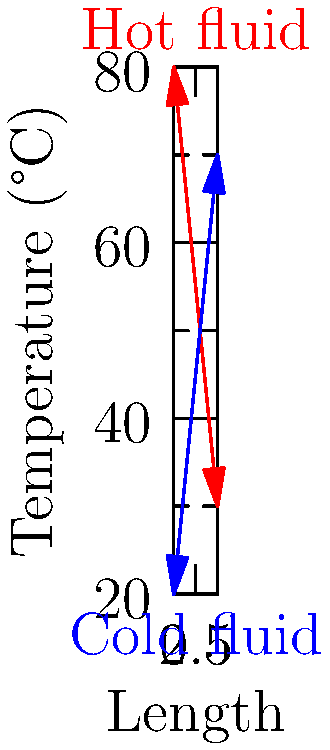In a counter-flow heat exchanger, the hot fluid enters at 80°C and exits at 30°C, while the cold fluid enters at 20°C and exits at 70°C. What is the log mean temperature difference (LMTD) for this heat exchanger? To calculate the log mean temperature difference (LMTD) for a counter-flow heat exchanger, we'll follow these steps:

1. Identify the temperature differences at both ends of the heat exchanger:
   $\Delta T_1 = T_{h,in} - T_{c,out} = 80°C - 70°C = 10°C$
   $\Delta T_2 = T_{h,out} - T_{c,in} = 30°C - 20°C = 10°C$

2. Apply the LMTD formula:
   $LMTD = \frac{\Delta T_1 - \Delta T_2}{\ln(\frac{\Delta T_1}{\Delta T_2})}$

3. Substitute the values:
   $LMTD = \frac{10°C - 10°C}{\ln(\frac{10°C}{10°C})}$

4. Simplify:
   $LMTD = \frac{0°C}{\ln(1)} = \frac{0}{0}$

5. Recognize that this is an indeterminate form. In this case, where $\Delta T_1 = \Delta T_2$, the LMTD is simply equal to either temperature difference.

Therefore, the LMTD for this heat exchanger is 10°C.

This result is particularly relevant for a startup founder implementing Ruby on Rails, as it demonstrates the importance of handling edge cases and potential mathematical singularities in software development, especially when dealing with engineering calculations.
Answer: 10°C 